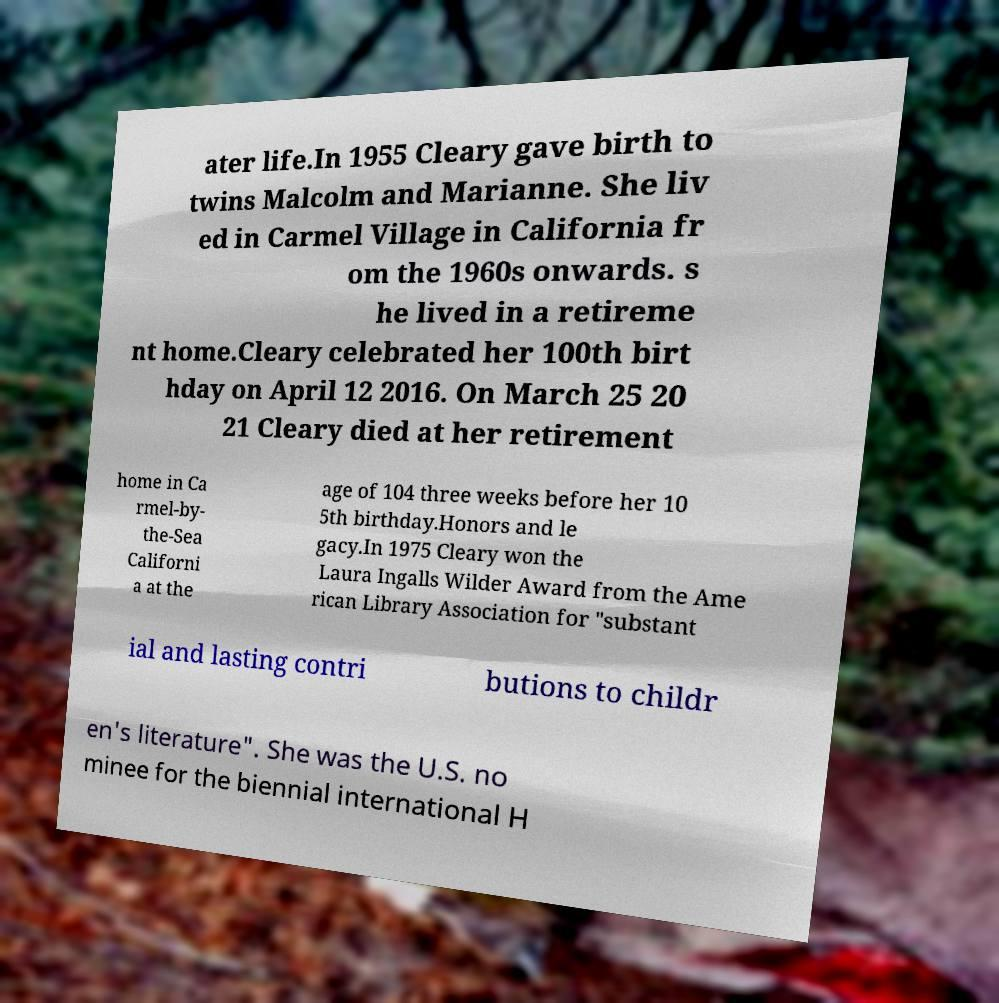Can you read and provide the text displayed in the image?This photo seems to have some interesting text. Can you extract and type it out for me? ater life.In 1955 Cleary gave birth to twins Malcolm and Marianne. She liv ed in Carmel Village in California fr om the 1960s onwards. s he lived in a retireme nt home.Cleary celebrated her 100th birt hday on April 12 2016. On March 25 20 21 Cleary died at her retirement home in Ca rmel-by- the-Sea Californi a at the age of 104 three weeks before her 10 5th birthday.Honors and le gacy.In 1975 Cleary won the Laura Ingalls Wilder Award from the Ame rican Library Association for "substant ial and lasting contri butions to childr en's literature". She was the U.S. no minee for the biennial international H 